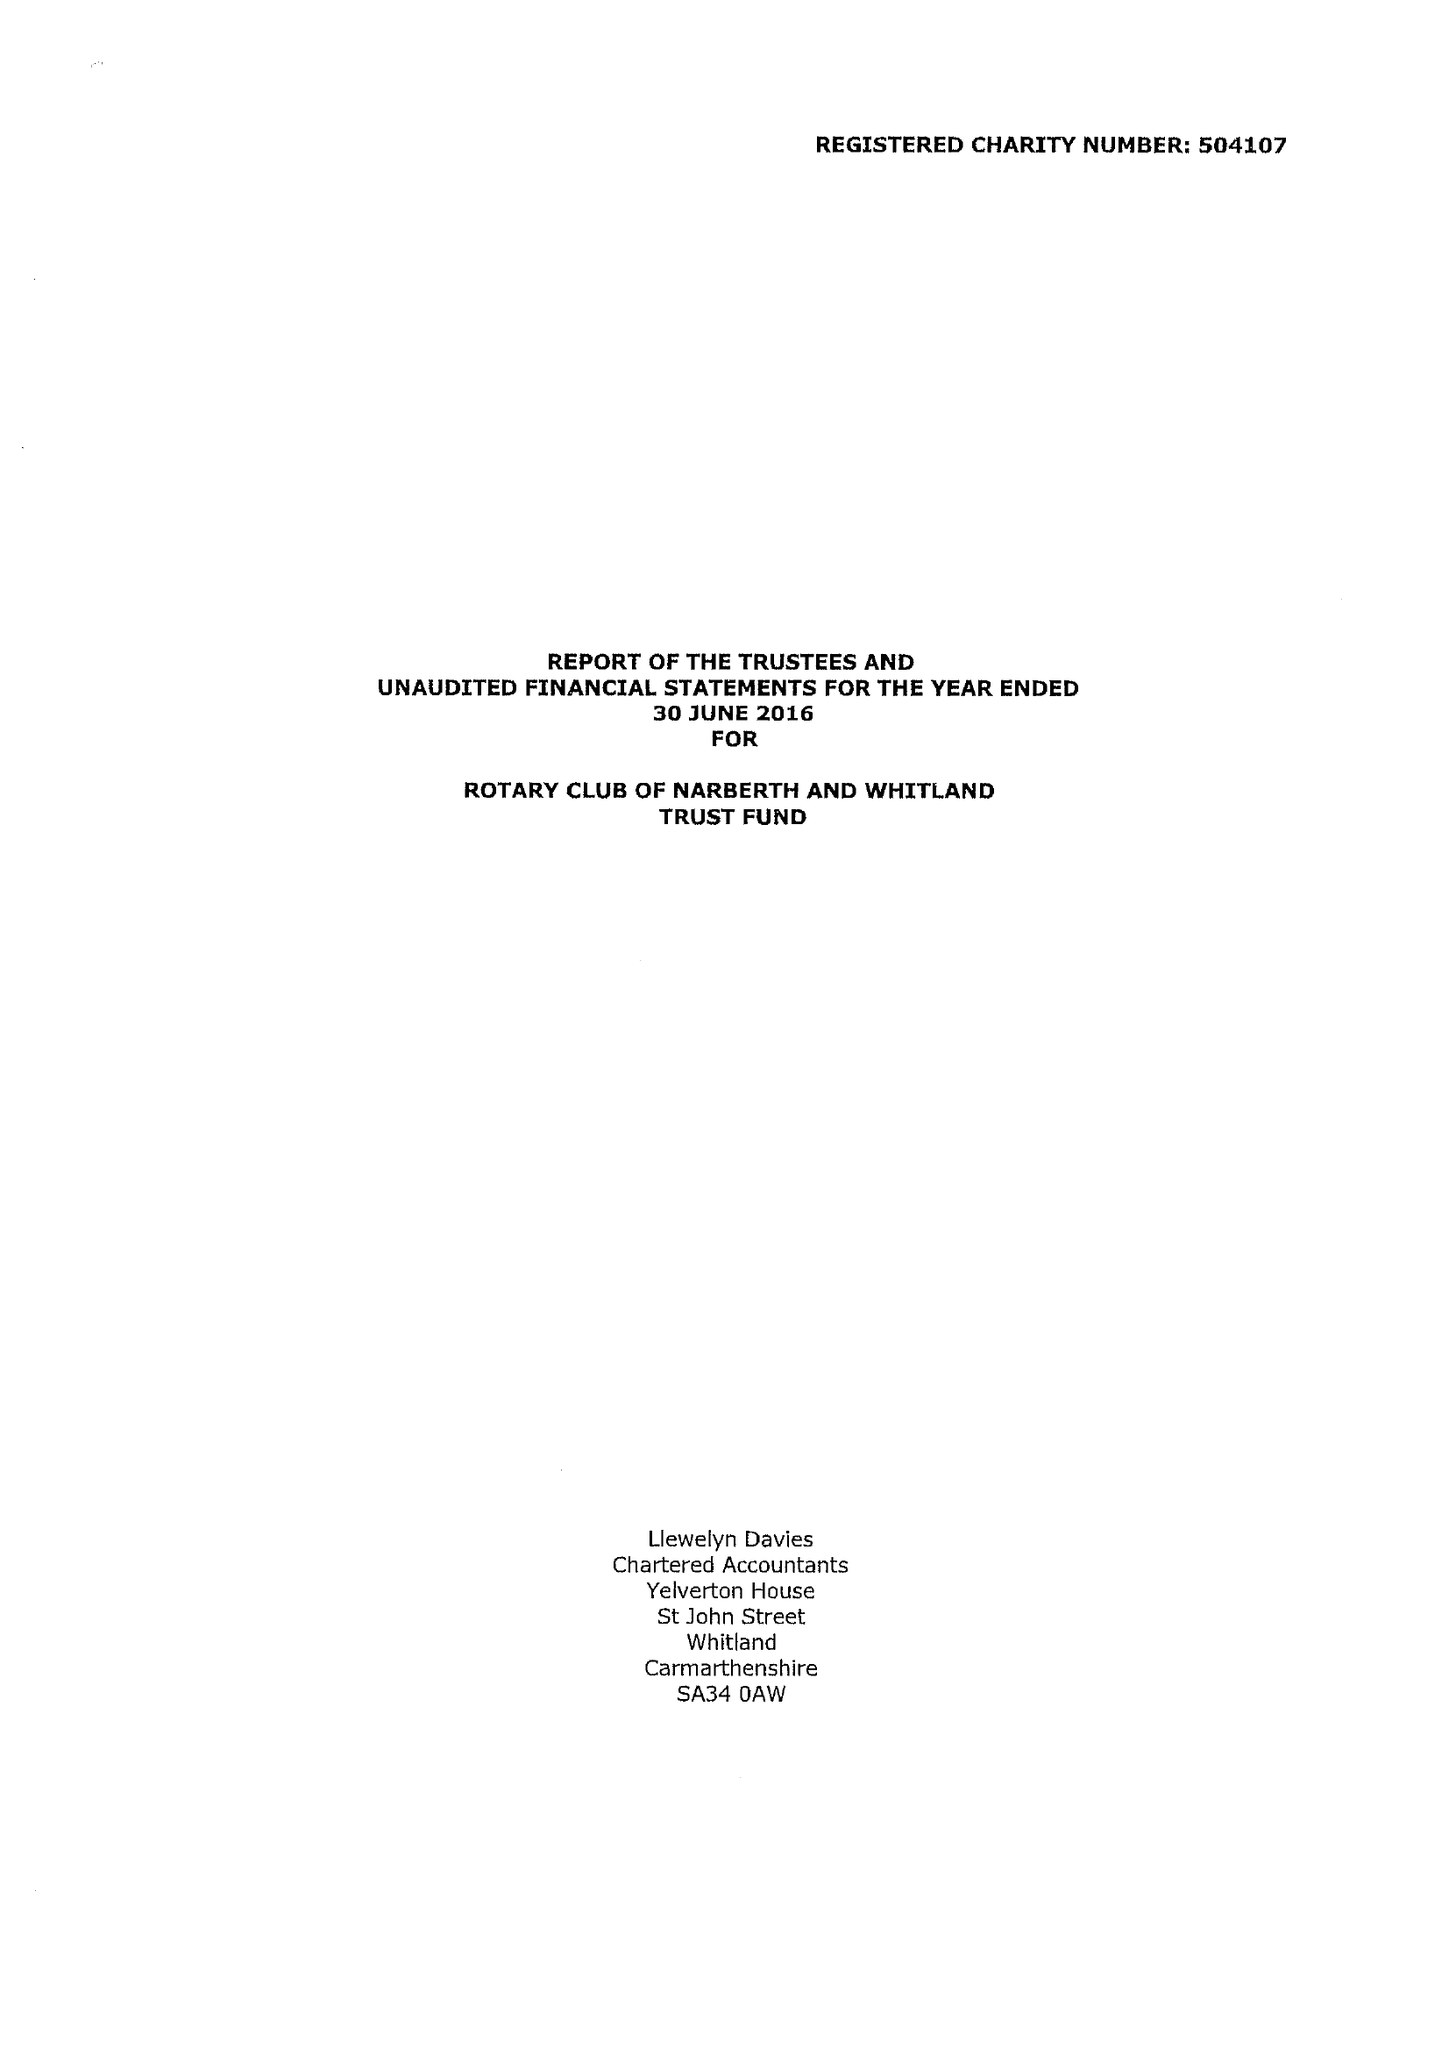What is the value for the charity_number?
Answer the question using a single word or phrase. 504107 